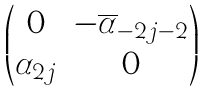<formula> <loc_0><loc_0><loc_500><loc_500>\begin{pmatrix} 0 & - \overline { \alpha } _ { - 2 j - 2 } \\ \alpha _ { 2 j } & 0 \end{pmatrix}</formula> 